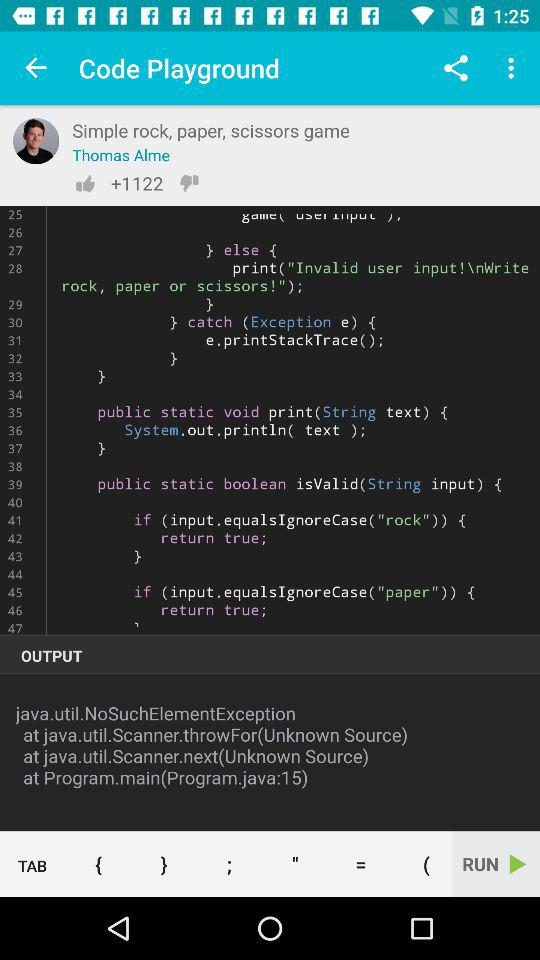What is the name of given user? The name of the given user is Thomas Alme. 